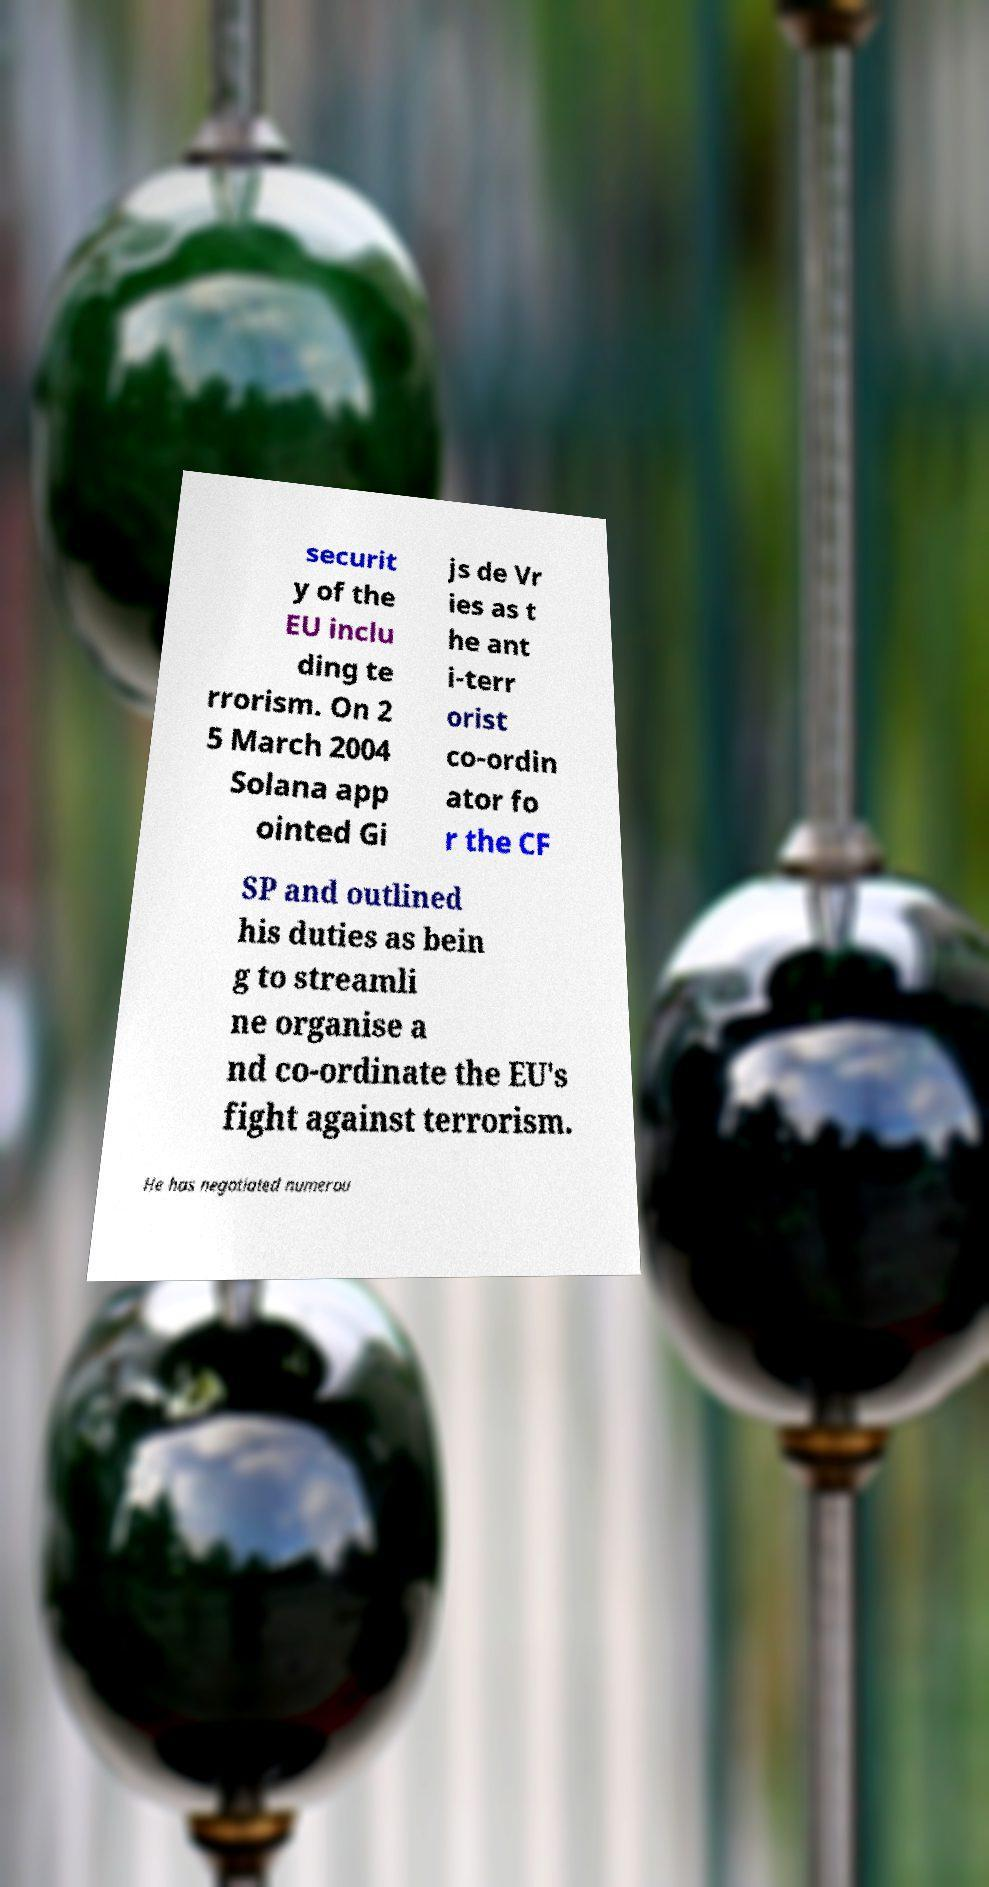Please identify and transcribe the text found in this image. securit y of the EU inclu ding te rrorism. On 2 5 March 2004 Solana app ointed Gi js de Vr ies as t he ant i-terr orist co-ordin ator fo r the CF SP and outlined his duties as bein g to streamli ne organise a nd co-ordinate the EU's fight against terrorism. He has negotiated numerou 